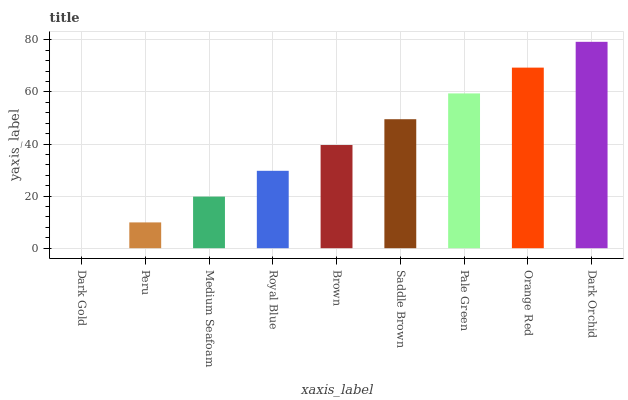Is Dark Gold the minimum?
Answer yes or no. Yes. Is Dark Orchid the maximum?
Answer yes or no. Yes. Is Peru the minimum?
Answer yes or no. No. Is Peru the maximum?
Answer yes or no. No. Is Peru greater than Dark Gold?
Answer yes or no. Yes. Is Dark Gold less than Peru?
Answer yes or no. Yes. Is Dark Gold greater than Peru?
Answer yes or no. No. Is Peru less than Dark Gold?
Answer yes or no. No. Is Brown the high median?
Answer yes or no. Yes. Is Brown the low median?
Answer yes or no. Yes. Is Peru the high median?
Answer yes or no. No. Is Pale Green the low median?
Answer yes or no. No. 